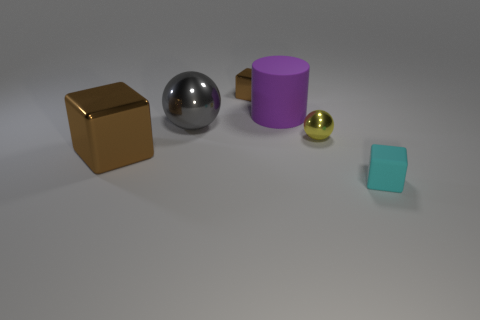Add 2 large yellow metal cubes. How many objects exist? 8 Subtract all balls. How many objects are left? 4 Add 6 big cylinders. How many big cylinders exist? 7 Subtract 0 green cylinders. How many objects are left? 6 Subtract all rubber cylinders. Subtract all small red cubes. How many objects are left? 5 Add 4 large gray objects. How many large gray objects are left? 5 